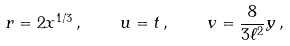Convert formula to latex. <formula><loc_0><loc_0><loc_500><loc_500>r = 2 x ^ { 1 / 3 } \, , \quad u = t \, , \quad v = \frac { 8 } { 3 \ell ^ { 2 } } y \, ,</formula> 